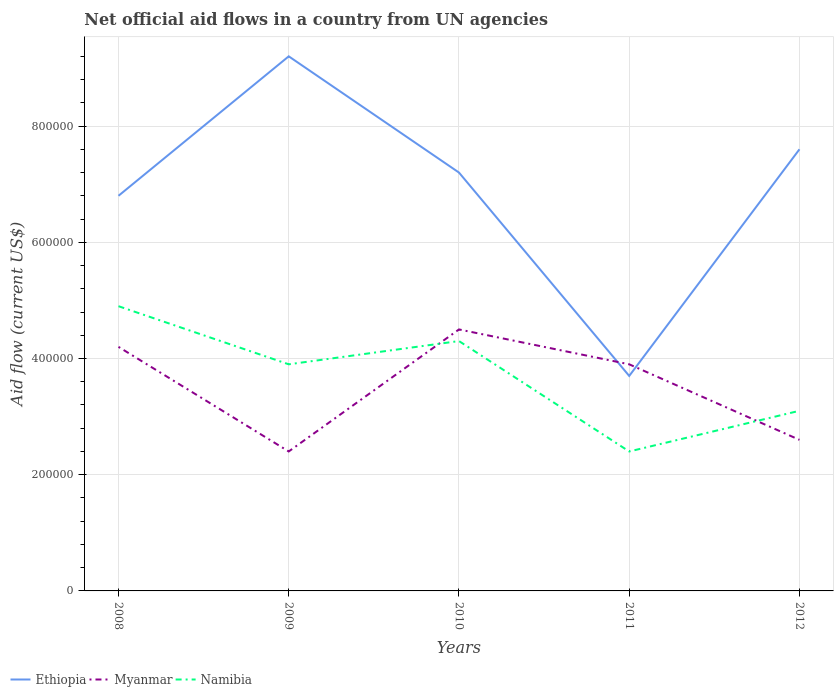How many different coloured lines are there?
Your answer should be very brief. 3. Is the number of lines equal to the number of legend labels?
Offer a terse response. Yes. Across all years, what is the maximum net official aid flow in Namibia?
Keep it short and to the point. 2.40e+05. What is the total net official aid flow in Namibia in the graph?
Make the answer very short. -4.00e+04. What is the difference between the highest and the second highest net official aid flow in Namibia?
Your answer should be very brief. 2.50e+05. What is the difference between the highest and the lowest net official aid flow in Myanmar?
Give a very brief answer. 3. Is the net official aid flow in Myanmar strictly greater than the net official aid flow in Namibia over the years?
Offer a very short reply. No. How many lines are there?
Make the answer very short. 3. How many years are there in the graph?
Your response must be concise. 5. What is the difference between two consecutive major ticks on the Y-axis?
Give a very brief answer. 2.00e+05. Are the values on the major ticks of Y-axis written in scientific E-notation?
Give a very brief answer. No. Does the graph contain any zero values?
Your response must be concise. No. What is the title of the graph?
Your response must be concise. Net official aid flows in a country from UN agencies. Does "Mali" appear as one of the legend labels in the graph?
Your answer should be very brief. No. What is the label or title of the Y-axis?
Make the answer very short. Aid flow (current US$). What is the Aid flow (current US$) of Ethiopia in 2008?
Provide a succinct answer. 6.80e+05. What is the Aid flow (current US$) in Namibia in 2008?
Your answer should be compact. 4.90e+05. What is the Aid flow (current US$) of Ethiopia in 2009?
Provide a short and direct response. 9.20e+05. What is the Aid flow (current US$) of Myanmar in 2009?
Offer a very short reply. 2.40e+05. What is the Aid flow (current US$) in Ethiopia in 2010?
Keep it short and to the point. 7.20e+05. What is the Aid flow (current US$) in Ethiopia in 2011?
Provide a succinct answer. 3.70e+05. What is the Aid flow (current US$) in Ethiopia in 2012?
Give a very brief answer. 7.60e+05. What is the Aid flow (current US$) in Myanmar in 2012?
Provide a succinct answer. 2.60e+05. What is the Aid flow (current US$) in Namibia in 2012?
Give a very brief answer. 3.10e+05. Across all years, what is the maximum Aid flow (current US$) of Ethiopia?
Your answer should be compact. 9.20e+05. Across all years, what is the maximum Aid flow (current US$) of Myanmar?
Provide a succinct answer. 4.50e+05. Across all years, what is the maximum Aid flow (current US$) of Namibia?
Your response must be concise. 4.90e+05. Across all years, what is the minimum Aid flow (current US$) of Myanmar?
Keep it short and to the point. 2.40e+05. What is the total Aid flow (current US$) in Ethiopia in the graph?
Your response must be concise. 3.45e+06. What is the total Aid flow (current US$) in Myanmar in the graph?
Make the answer very short. 1.76e+06. What is the total Aid flow (current US$) in Namibia in the graph?
Provide a short and direct response. 1.86e+06. What is the difference between the Aid flow (current US$) of Ethiopia in 2008 and that in 2009?
Offer a terse response. -2.40e+05. What is the difference between the Aid flow (current US$) in Namibia in 2008 and that in 2010?
Your answer should be compact. 6.00e+04. What is the difference between the Aid flow (current US$) in Ethiopia in 2008 and that in 2011?
Provide a succinct answer. 3.10e+05. What is the difference between the Aid flow (current US$) in Ethiopia in 2008 and that in 2012?
Provide a short and direct response. -8.00e+04. What is the difference between the Aid flow (current US$) in Myanmar in 2009 and that in 2010?
Your answer should be compact. -2.10e+05. What is the difference between the Aid flow (current US$) in Ethiopia in 2009 and that in 2012?
Keep it short and to the point. 1.60e+05. What is the difference between the Aid flow (current US$) of Myanmar in 2009 and that in 2012?
Your answer should be very brief. -2.00e+04. What is the difference between the Aid flow (current US$) in Namibia in 2009 and that in 2012?
Give a very brief answer. 8.00e+04. What is the difference between the Aid flow (current US$) in Namibia in 2010 and that in 2011?
Make the answer very short. 1.90e+05. What is the difference between the Aid flow (current US$) of Ethiopia in 2010 and that in 2012?
Your response must be concise. -4.00e+04. What is the difference between the Aid flow (current US$) of Myanmar in 2010 and that in 2012?
Your answer should be compact. 1.90e+05. What is the difference between the Aid flow (current US$) in Namibia in 2010 and that in 2012?
Your response must be concise. 1.20e+05. What is the difference between the Aid flow (current US$) of Ethiopia in 2011 and that in 2012?
Ensure brevity in your answer.  -3.90e+05. What is the difference between the Aid flow (current US$) in Myanmar in 2011 and that in 2012?
Your answer should be compact. 1.30e+05. What is the difference between the Aid flow (current US$) in Namibia in 2011 and that in 2012?
Your answer should be compact. -7.00e+04. What is the difference between the Aid flow (current US$) in Ethiopia in 2008 and the Aid flow (current US$) in Myanmar in 2009?
Your answer should be compact. 4.40e+05. What is the difference between the Aid flow (current US$) of Ethiopia in 2008 and the Aid flow (current US$) of Namibia in 2009?
Offer a terse response. 2.90e+05. What is the difference between the Aid flow (current US$) of Myanmar in 2008 and the Aid flow (current US$) of Namibia in 2009?
Make the answer very short. 3.00e+04. What is the difference between the Aid flow (current US$) in Ethiopia in 2008 and the Aid flow (current US$) in Namibia in 2010?
Provide a succinct answer. 2.50e+05. What is the difference between the Aid flow (current US$) in Ethiopia in 2008 and the Aid flow (current US$) in Namibia in 2011?
Ensure brevity in your answer.  4.40e+05. What is the difference between the Aid flow (current US$) of Ethiopia in 2008 and the Aid flow (current US$) of Myanmar in 2012?
Your answer should be compact. 4.20e+05. What is the difference between the Aid flow (current US$) in Myanmar in 2008 and the Aid flow (current US$) in Namibia in 2012?
Offer a terse response. 1.10e+05. What is the difference between the Aid flow (current US$) of Ethiopia in 2009 and the Aid flow (current US$) of Myanmar in 2010?
Provide a succinct answer. 4.70e+05. What is the difference between the Aid flow (current US$) of Ethiopia in 2009 and the Aid flow (current US$) of Myanmar in 2011?
Give a very brief answer. 5.30e+05. What is the difference between the Aid flow (current US$) in Ethiopia in 2009 and the Aid flow (current US$) in Namibia in 2011?
Your response must be concise. 6.80e+05. What is the difference between the Aid flow (current US$) of Myanmar in 2009 and the Aid flow (current US$) of Namibia in 2011?
Your response must be concise. 0. What is the difference between the Aid flow (current US$) in Ethiopia in 2009 and the Aid flow (current US$) in Myanmar in 2012?
Keep it short and to the point. 6.60e+05. What is the difference between the Aid flow (current US$) in Myanmar in 2009 and the Aid flow (current US$) in Namibia in 2012?
Your response must be concise. -7.00e+04. What is the difference between the Aid flow (current US$) of Ethiopia in 2010 and the Aid flow (current US$) of Namibia in 2011?
Your answer should be compact. 4.80e+05. What is the difference between the Aid flow (current US$) in Myanmar in 2010 and the Aid flow (current US$) in Namibia in 2011?
Make the answer very short. 2.10e+05. What is the difference between the Aid flow (current US$) of Ethiopia in 2010 and the Aid flow (current US$) of Namibia in 2012?
Ensure brevity in your answer.  4.10e+05. What is the difference between the Aid flow (current US$) in Myanmar in 2010 and the Aid flow (current US$) in Namibia in 2012?
Offer a terse response. 1.40e+05. What is the difference between the Aid flow (current US$) in Ethiopia in 2011 and the Aid flow (current US$) in Myanmar in 2012?
Make the answer very short. 1.10e+05. What is the difference between the Aid flow (current US$) in Ethiopia in 2011 and the Aid flow (current US$) in Namibia in 2012?
Your answer should be compact. 6.00e+04. What is the difference between the Aid flow (current US$) of Myanmar in 2011 and the Aid flow (current US$) of Namibia in 2012?
Your answer should be very brief. 8.00e+04. What is the average Aid flow (current US$) in Ethiopia per year?
Keep it short and to the point. 6.90e+05. What is the average Aid flow (current US$) in Myanmar per year?
Ensure brevity in your answer.  3.52e+05. What is the average Aid flow (current US$) of Namibia per year?
Offer a very short reply. 3.72e+05. In the year 2008, what is the difference between the Aid flow (current US$) of Ethiopia and Aid flow (current US$) of Myanmar?
Provide a short and direct response. 2.60e+05. In the year 2009, what is the difference between the Aid flow (current US$) of Ethiopia and Aid flow (current US$) of Myanmar?
Ensure brevity in your answer.  6.80e+05. In the year 2009, what is the difference between the Aid flow (current US$) of Ethiopia and Aid flow (current US$) of Namibia?
Make the answer very short. 5.30e+05. In the year 2009, what is the difference between the Aid flow (current US$) of Myanmar and Aid flow (current US$) of Namibia?
Your answer should be compact. -1.50e+05. In the year 2010, what is the difference between the Aid flow (current US$) in Myanmar and Aid flow (current US$) in Namibia?
Offer a terse response. 2.00e+04. In the year 2011, what is the difference between the Aid flow (current US$) of Ethiopia and Aid flow (current US$) of Myanmar?
Your response must be concise. -2.00e+04. In the year 2011, what is the difference between the Aid flow (current US$) of Ethiopia and Aid flow (current US$) of Namibia?
Your answer should be very brief. 1.30e+05. In the year 2011, what is the difference between the Aid flow (current US$) of Myanmar and Aid flow (current US$) of Namibia?
Keep it short and to the point. 1.50e+05. In the year 2012, what is the difference between the Aid flow (current US$) of Ethiopia and Aid flow (current US$) of Myanmar?
Ensure brevity in your answer.  5.00e+05. In the year 2012, what is the difference between the Aid flow (current US$) of Myanmar and Aid flow (current US$) of Namibia?
Ensure brevity in your answer.  -5.00e+04. What is the ratio of the Aid flow (current US$) of Ethiopia in 2008 to that in 2009?
Keep it short and to the point. 0.74. What is the ratio of the Aid flow (current US$) in Myanmar in 2008 to that in 2009?
Offer a very short reply. 1.75. What is the ratio of the Aid flow (current US$) of Namibia in 2008 to that in 2009?
Offer a terse response. 1.26. What is the ratio of the Aid flow (current US$) of Myanmar in 2008 to that in 2010?
Keep it short and to the point. 0.93. What is the ratio of the Aid flow (current US$) of Namibia in 2008 to that in 2010?
Make the answer very short. 1.14. What is the ratio of the Aid flow (current US$) in Ethiopia in 2008 to that in 2011?
Your answer should be very brief. 1.84. What is the ratio of the Aid flow (current US$) in Namibia in 2008 to that in 2011?
Make the answer very short. 2.04. What is the ratio of the Aid flow (current US$) of Ethiopia in 2008 to that in 2012?
Offer a very short reply. 0.89. What is the ratio of the Aid flow (current US$) of Myanmar in 2008 to that in 2012?
Your response must be concise. 1.62. What is the ratio of the Aid flow (current US$) in Namibia in 2008 to that in 2012?
Your response must be concise. 1.58. What is the ratio of the Aid flow (current US$) of Ethiopia in 2009 to that in 2010?
Keep it short and to the point. 1.28. What is the ratio of the Aid flow (current US$) in Myanmar in 2009 to that in 2010?
Offer a terse response. 0.53. What is the ratio of the Aid flow (current US$) in Namibia in 2009 to that in 2010?
Give a very brief answer. 0.91. What is the ratio of the Aid flow (current US$) in Ethiopia in 2009 to that in 2011?
Your answer should be very brief. 2.49. What is the ratio of the Aid flow (current US$) of Myanmar in 2009 to that in 2011?
Your answer should be compact. 0.62. What is the ratio of the Aid flow (current US$) in Namibia in 2009 to that in 2011?
Your response must be concise. 1.62. What is the ratio of the Aid flow (current US$) in Ethiopia in 2009 to that in 2012?
Keep it short and to the point. 1.21. What is the ratio of the Aid flow (current US$) of Myanmar in 2009 to that in 2012?
Provide a short and direct response. 0.92. What is the ratio of the Aid flow (current US$) of Namibia in 2009 to that in 2012?
Your answer should be very brief. 1.26. What is the ratio of the Aid flow (current US$) in Ethiopia in 2010 to that in 2011?
Ensure brevity in your answer.  1.95. What is the ratio of the Aid flow (current US$) of Myanmar in 2010 to that in 2011?
Your answer should be compact. 1.15. What is the ratio of the Aid flow (current US$) of Namibia in 2010 to that in 2011?
Keep it short and to the point. 1.79. What is the ratio of the Aid flow (current US$) of Ethiopia in 2010 to that in 2012?
Your answer should be very brief. 0.95. What is the ratio of the Aid flow (current US$) of Myanmar in 2010 to that in 2012?
Provide a short and direct response. 1.73. What is the ratio of the Aid flow (current US$) of Namibia in 2010 to that in 2012?
Your response must be concise. 1.39. What is the ratio of the Aid flow (current US$) in Ethiopia in 2011 to that in 2012?
Keep it short and to the point. 0.49. What is the ratio of the Aid flow (current US$) of Myanmar in 2011 to that in 2012?
Keep it short and to the point. 1.5. What is the ratio of the Aid flow (current US$) in Namibia in 2011 to that in 2012?
Your answer should be compact. 0.77. What is the difference between the highest and the second highest Aid flow (current US$) in Myanmar?
Offer a very short reply. 3.00e+04. What is the difference between the highest and the lowest Aid flow (current US$) in Ethiopia?
Provide a succinct answer. 5.50e+05. What is the difference between the highest and the lowest Aid flow (current US$) of Namibia?
Your response must be concise. 2.50e+05. 